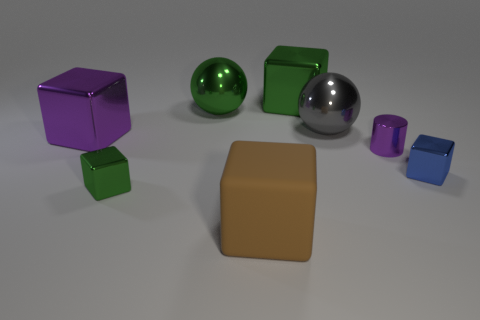How many big metal blocks are both to the right of the rubber block and on the left side of the large rubber object? 0 